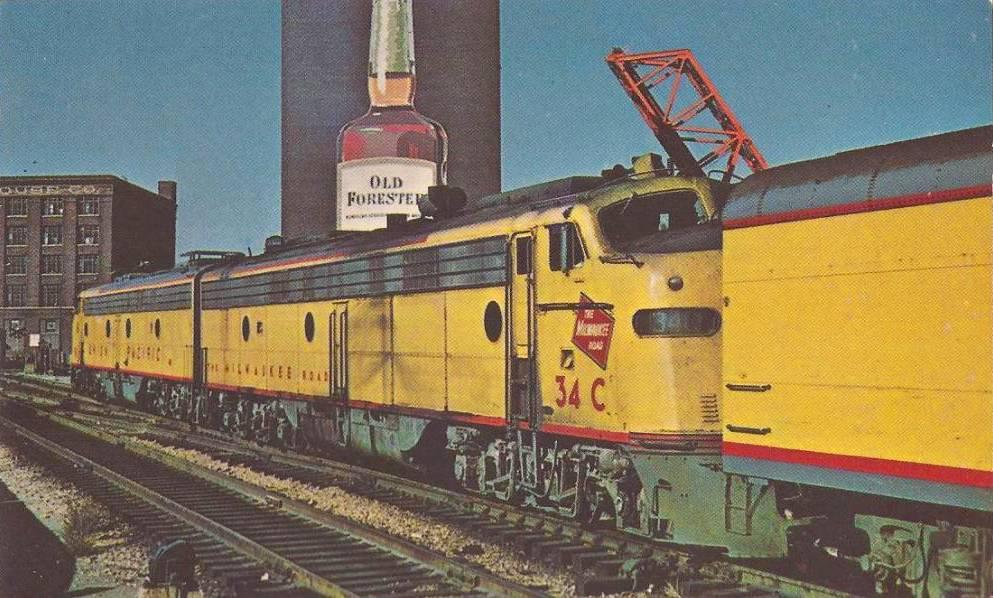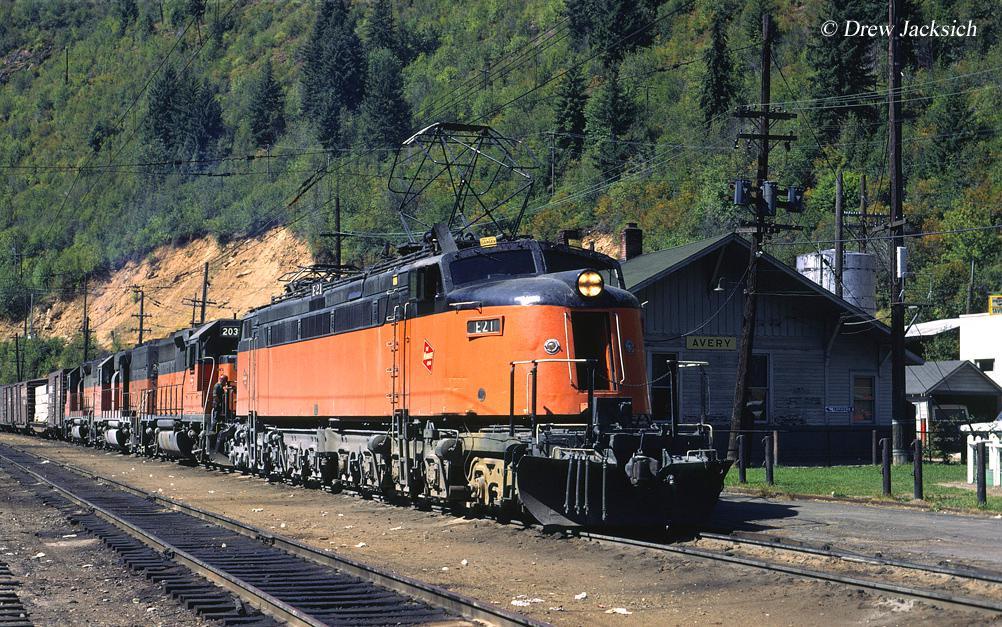The first image is the image on the left, the second image is the image on the right. Considering the images on both sides, is "There is a yellow train with red markings in one of the images." valid? Answer yes or no. Yes. The first image is the image on the left, the second image is the image on the right. Examine the images to the left and right. Is the description "An image shows a rightward angled orange and black train, with no bridge extending over it." accurate? Answer yes or no. Yes. 